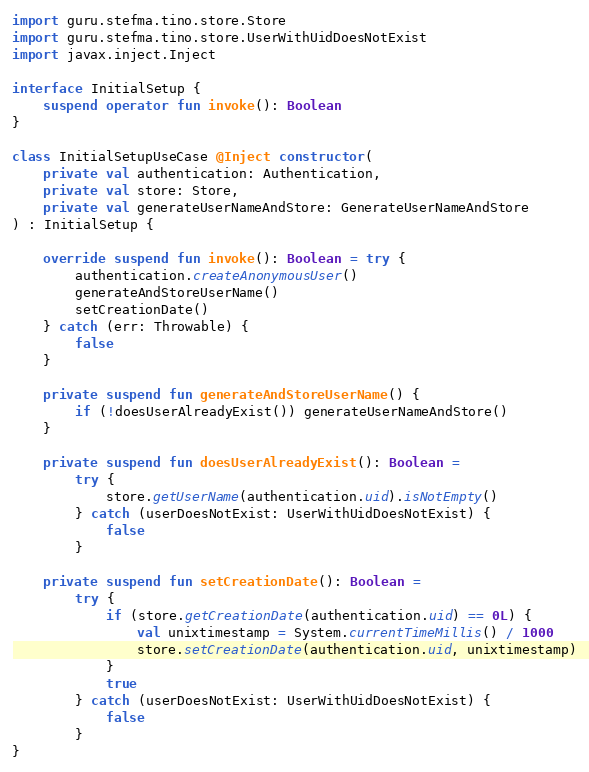<code> <loc_0><loc_0><loc_500><loc_500><_Kotlin_>import guru.stefma.tino.store.Store
import guru.stefma.tino.store.UserWithUidDoesNotExist
import javax.inject.Inject

interface InitialSetup {
    suspend operator fun invoke(): Boolean
}

class InitialSetupUseCase @Inject constructor(
    private val authentication: Authentication,
    private val store: Store,
    private val generateUserNameAndStore: GenerateUserNameAndStore
) : InitialSetup {

    override suspend fun invoke(): Boolean = try {
        authentication.createAnonymousUser()
        generateAndStoreUserName()
        setCreationDate()
    } catch (err: Throwable) {
        false
    }

    private suspend fun generateAndStoreUserName() {
        if (!doesUserAlreadyExist()) generateUserNameAndStore()
    }

    private suspend fun doesUserAlreadyExist(): Boolean =
        try {
            store.getUserName(authentication.uid).isNotEmpty()
        } catch (userDoesNotExist: UserWithUidDoesNotExist) {
            false
        }

    private suspend fun setCreationDate(): Boolean =
        try {
            if (store.getCreationDate(authentication.uid) == 0L) {
                val unixtimestamp = System.currentTimeMillis() / 1000
                store.setCreationDate(authentication.uid, unixtimestamp)
            }
            true
        } catch (userDoesNotExist: UserWithUidDoesNotExist) {
            false
        }
}</code> 